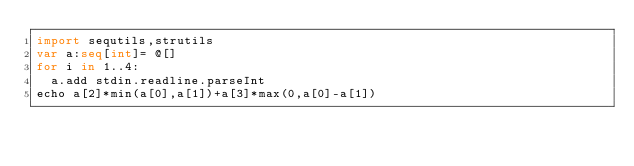Convert code to text. <code><loc_0><loc_0><loc_500><loc_500><_Nim_>import sequtils,strutils
var a:seq[int]= @[]
for i in 1..4:
  a.add stdin.readline.parseInt
echo a[2]*min(a[0],a[1])+a[3]*max(0,a[0]-a[1])</code> 